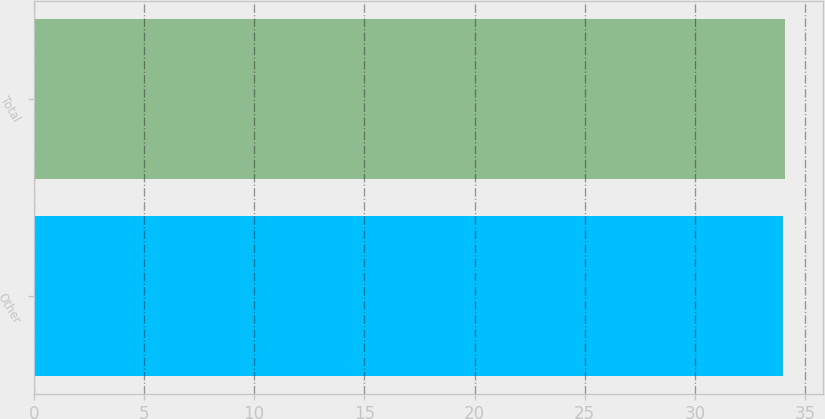<chart> <loc_0><loc_0><loc_500><loc_500><bar_chart><fcel>Other<fcel>Total<nl><fcel>34<fcel>34.1<nl></chart> 